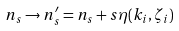<formula> <loc_0><loc_0><loc_500><loc_500>n _ { s } \to n ^ { \prime } _ { s } = n _ { s } + s \eta ( k _ { i } , \zeta _ { i } )</formula> 